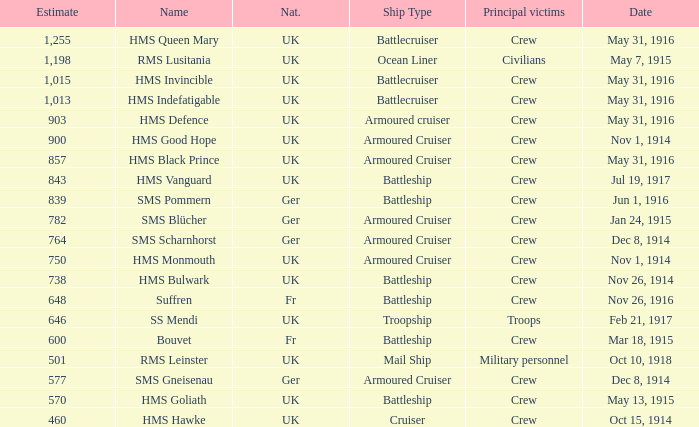What is the nationality of the ship when the principle victims are civilians? UK. 